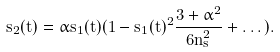<formula> <loc_0><loc_0><loc_500><loc_500>s _ { 2 } ( t ) = \alpha s _ { 1 } ( t ) ( 1 - s _ { 1 } ( t ) ^ { 2 } \frac { 3 + \alpha ^ { 2 } } { 6 n _ { s } ^ { 2 } } + \dots ) .</formula> 